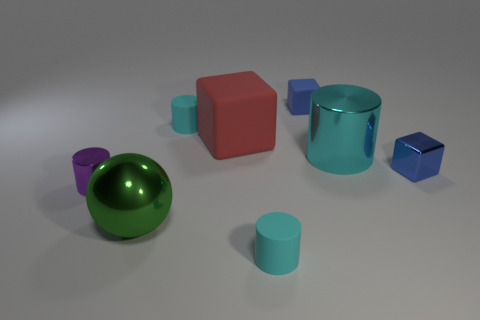What is the size of the blue block that is behind the cyan rubber cylinder that is to the left of the small rubber cylinder that is in front of the large green thing?
Provide a succinct answer. Small. There is a blue matte object; what shape is it?
Offer a terse response. Cube. What size is the other cube that is the same color as the small shiny cube?
Your response must be concise. Small. There is a blue thing to the right of the small blue matte thing; what number of tiny metallic objects are behind it?
Offer a very short reply. 0. What number of other things are made of the same material as the green object?
Your response must be concise. 3. Is the material of the red thing in front of the blue matte object the same as the big thing right of the red block?
Offer a terse response. No. Is there any other thing that has the same shape as the large cyan object?
Make the answer very short. Yes. Is the material of the red thing the same as the tiny cyan thing that is behind the ball?
Keep it short and to the point. Yes. There is a small rubber cylinder that is to the right of the tiny cyan matte thing that is on the left side of the tiny cyan rubber object that is in front of the big green object; what color is it?
Make the answer very short. Cyan. The cyan thing that is the same size as the ball is what shape?
Offer a very short reply. Cylinder. 